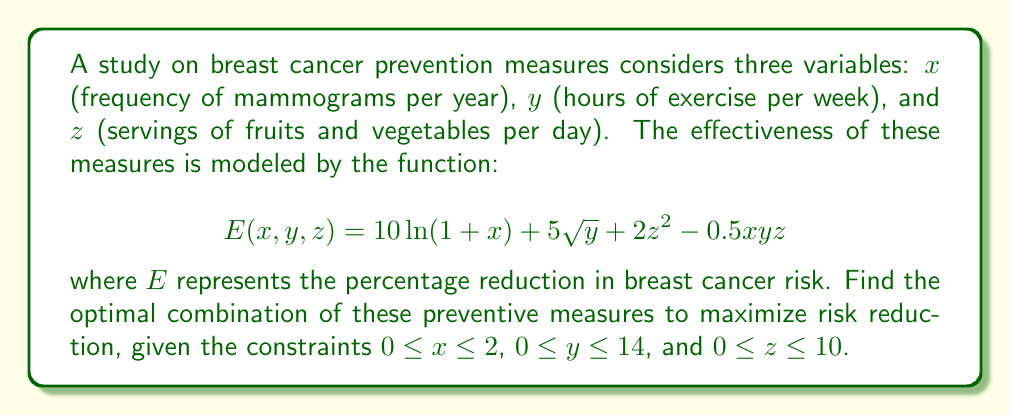Show me your answer to this math problem. To find the optimal combination, we need to use multivariable calculus techniques:

1) First, we calculate the partial derivatives of $E$ with respect to $x$, $y$, and $z$:

   $$\frac{\partial E}{\partial x} = \frac{10}{1+x} - 0.5yz$$
   $$\frac{\partial E}{\partial y} = \frac{5}{2\sqrt{y}} - 0.5xz$$
   $$\frac{\partial E}{\partial z} = 4z - 0.5xy$$

2) Set each partial derivative to zero and solve the system of equations:

   $$\frac{10}{1+x} - 0.5yz = 0$$
   $$\frac{5}{2\sqrt{y}} - 0.5xz = 0$$
   $$4z - 0.5xy = 0$$

3) From the third equation: $z = \frac{xy}{8}$

4) Substitute this into the first two equations:

   $$\frac{10}{1+x} - 0.5y(\frac{xy}{8}) = 0$$
   $$\frac{5}{2\sqrt{y}} - 0.5x(\frac{xy}{8}) = 0$$

5) Simplify:

   $$\frac{80}{1+x} = x^2y$$
   $$\frac{40}{\sqrt{y}} = x^2y$$

6) Equate these:

   $$\frac{80}{1+x} = \frac{40}{\sqrt{y}}$$

7) Solve for $y$:

   $$y = (\frac{1+x}{2})^2$$

8) Substitute back into $z = \frac{xy}{8}$:

   $$z = \frac{x(\frac{1+x}{2})^2}{8} = \frac{(1+x)^2}{32}$$

9) Check the boundaries:

   For $x$: When $x = 2$, $y \approx 2.25$ and $z \approx 0.28$
   For $y$: When $y = 14$, $x \approx 6.5$ (out of range)
   For $z$: When $z = 10$, $x \approx 17.9$ (out of range)

10) The optimal point within the given constraints is $(2, 2.25, 0.28)$.

11) Calculate the maximum $E$:

    $$E(2, 2.25, 0.28) \approx 21.76$$

Therefore, the optimal combination is approximately 2 mammograms per year, 2.25 hours of exercise per week, and 0.28 servings of fruits and vegetables per day, resulting in a 21.76% reduction in breast cancer risk.
Answer: $(x,y,z) \approx (2, 2.25, 0.28)$; $E_{max} \approx 21.76\%$ 